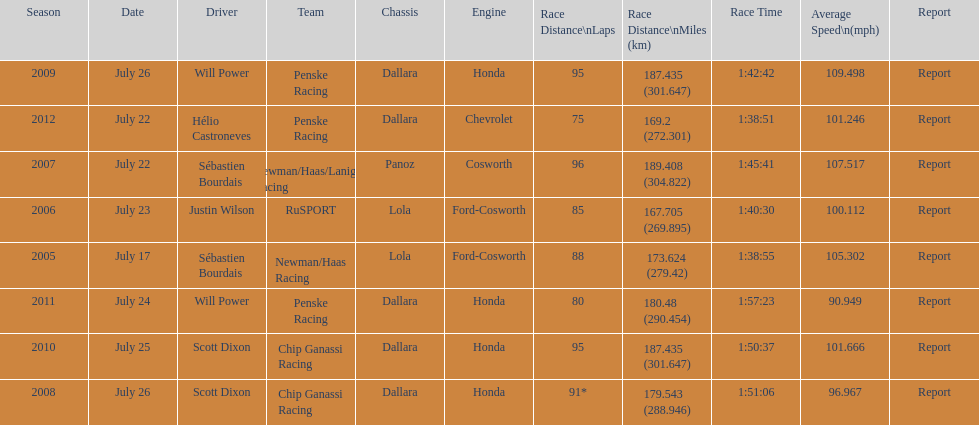What is the total number dallara chassis listed in the table? 5. 